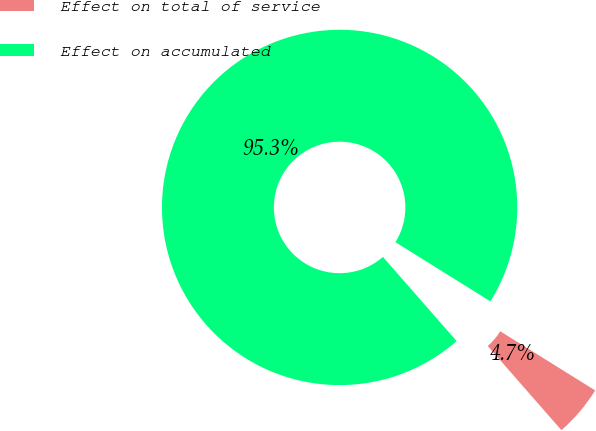<chart> <loc_0><loc_0><loc_500><loc_500><pie_chart><fcel>Effect on total of service<fcel>Effect on accumulated<nl><fcel>4.69%<fcel>95.31%<nl></chart> 